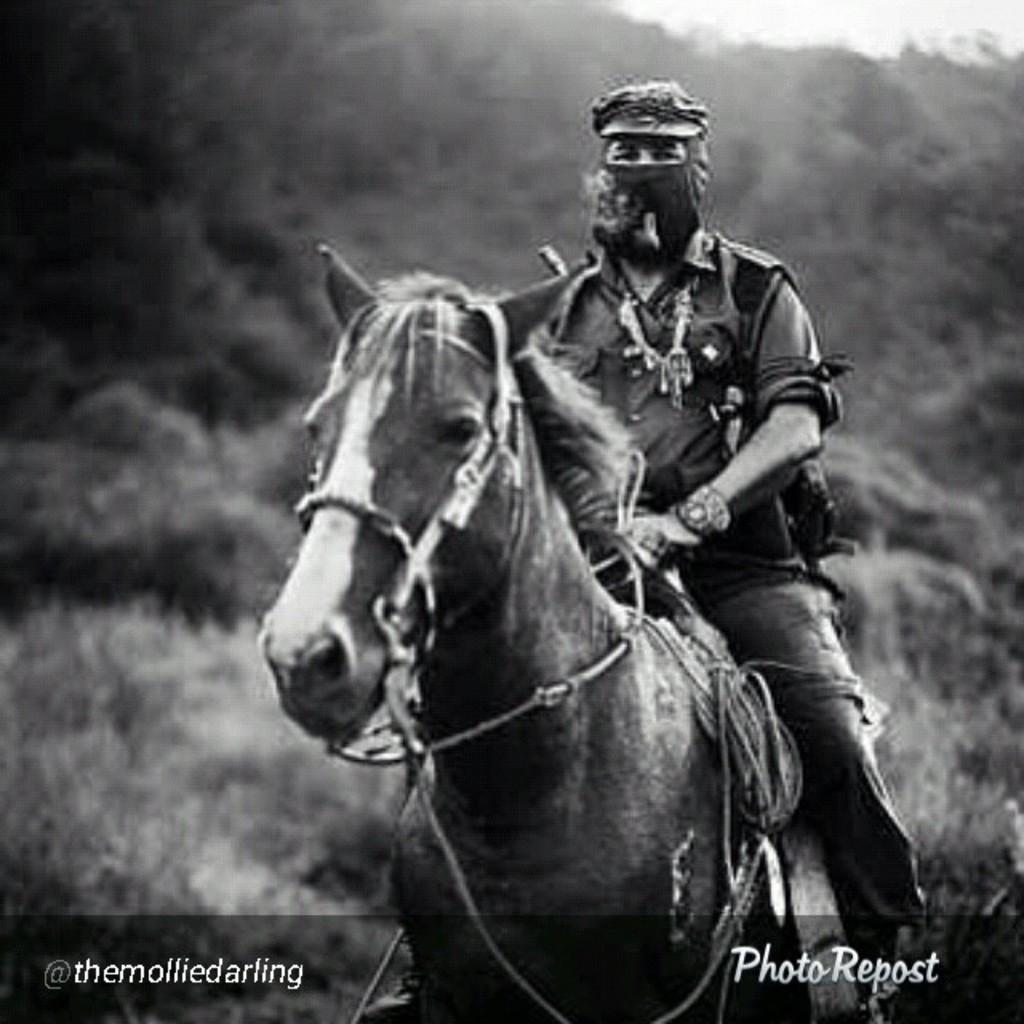What is the main subject of the image? There is a person in the image. What accessories is the person wearing? The person is wearing a scarf and a cap. What is the person doing in the image? The person is sitting on a horse. Can you tell me how many cats are present in the image? There are no cats present in the image; it features a person sitting on a horse. What type of journey is the person taking in the image? The image does not provide information about the person's journey; it only shows them sitting on a horse. 